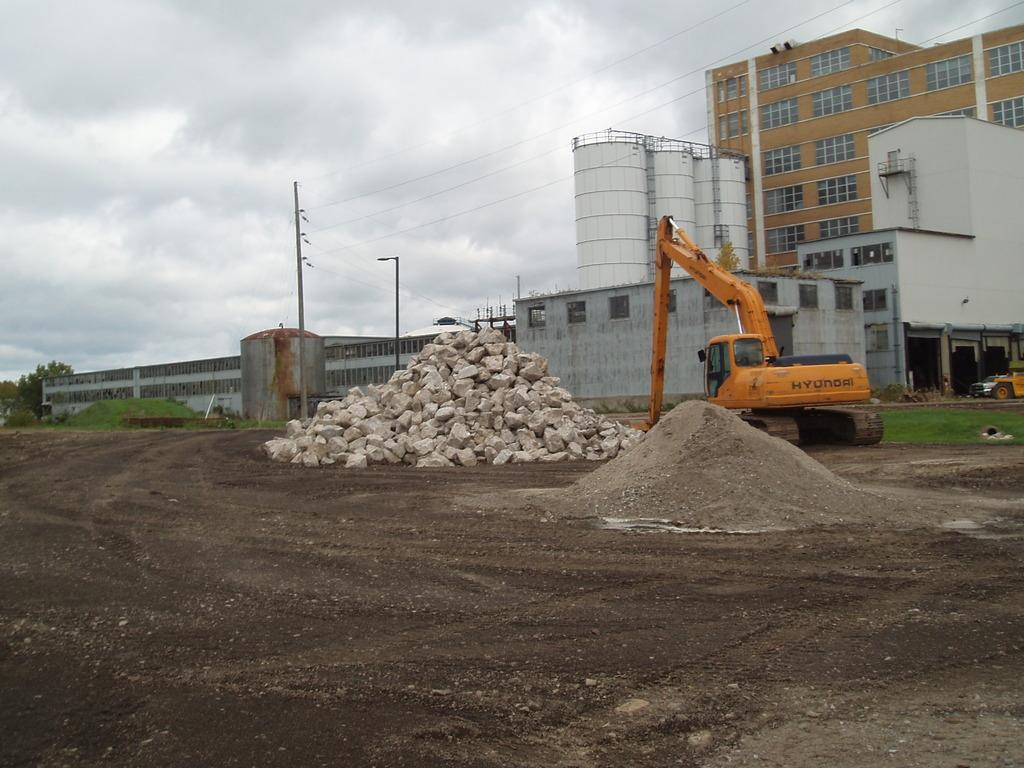What is the main subject of the image? There is a vehicle in the image. What type of terrain is visible in the image? Sand, stones, grass, and trees are visible in the image. What type of structure is present in the image? There is a building in the image, and its windows are visible. What man-made objects are present in the image? An electric pole and electric wires are present in the image. What is the weather like in the image? The sky is cloudy in the image. Can you explain the scientific theory behind the lake in the image? There is no lake present in the image, so it is not possible to discuss a scientific theory related to it. 